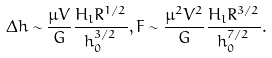Convert formula to latex. <formula><loc_0><loc_0><loc_500><loc_500>\Delta h \sim \frac { \mu V } { G } \frac { H _ { l } R ^ { 1 / 2 } } { h _ { 0 } ^ { 3 / 2 } } , F \sim \frac { \mu ^ { 2 } V ^ { 2 } } { G } \frac { H _ { l } R ^ { 3 / 2 } } { h _ { 0 } ^ { 7 / 2 } } .</formula> 